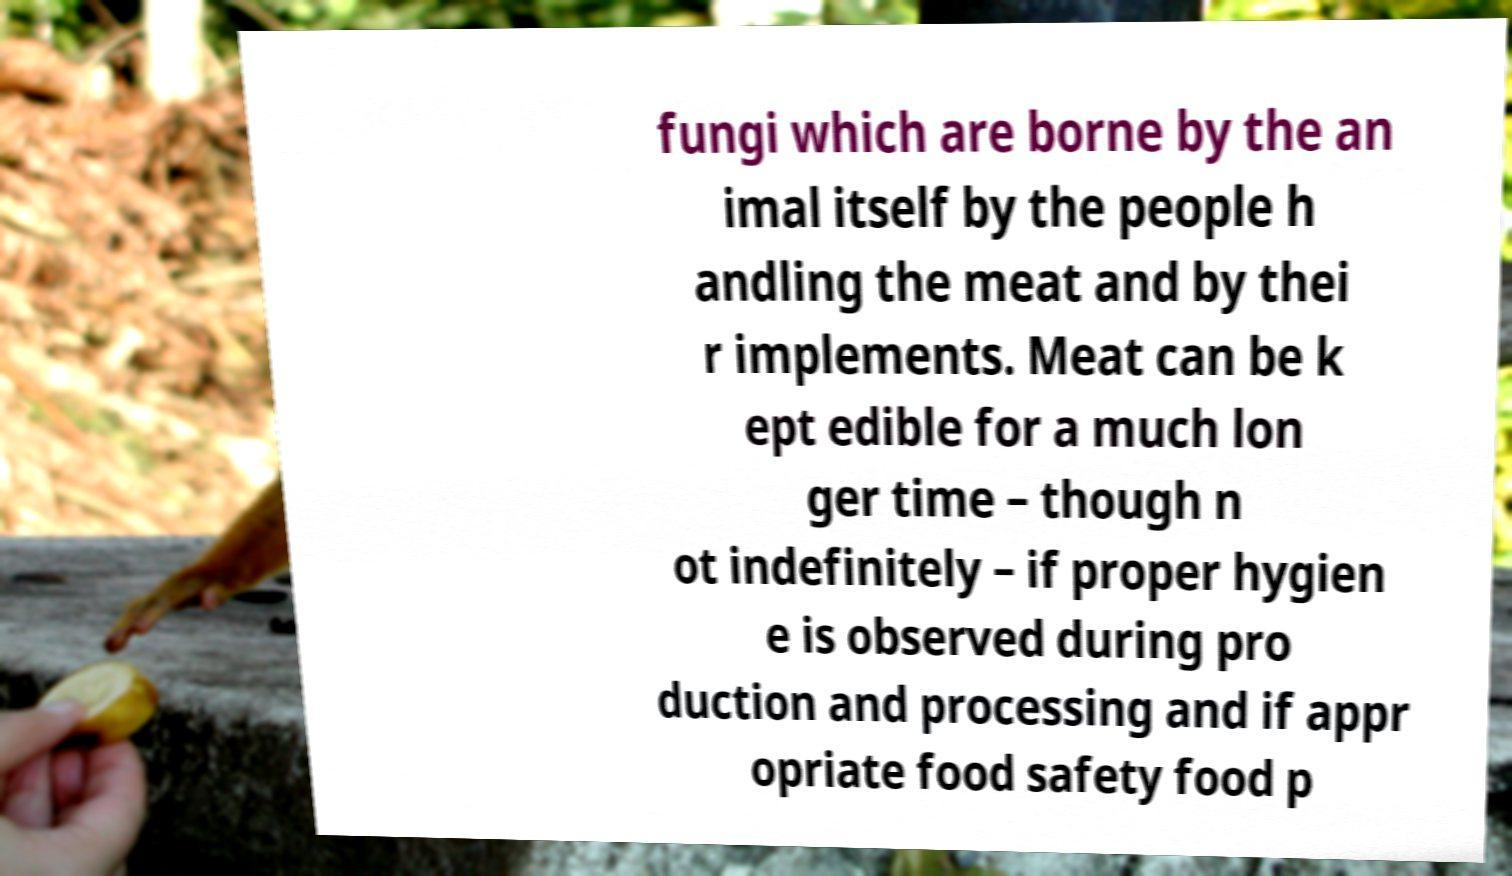Could you assist in decoding the text presented in this image and type it out clearly? fungi which are borne by the an imal itself by the people h andling the meat and by thei r implements. Meat can be k ept edible for a much lon ger time – though n ot indefinitely – if proper hygien e is observed during pro duction and processing and if appr opriate food safety food p 